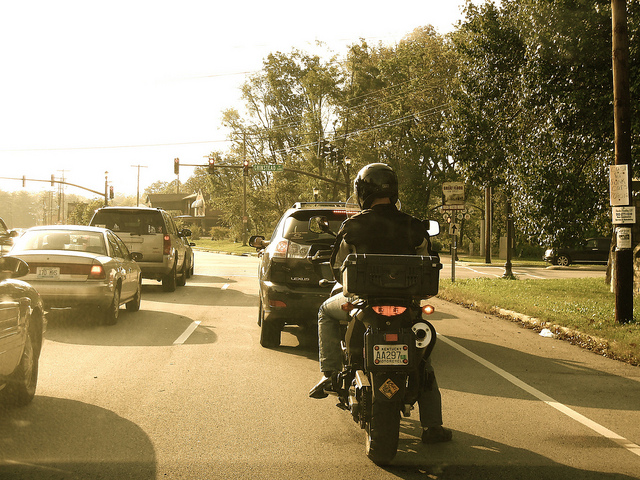Please extract the text content from this image. 297 